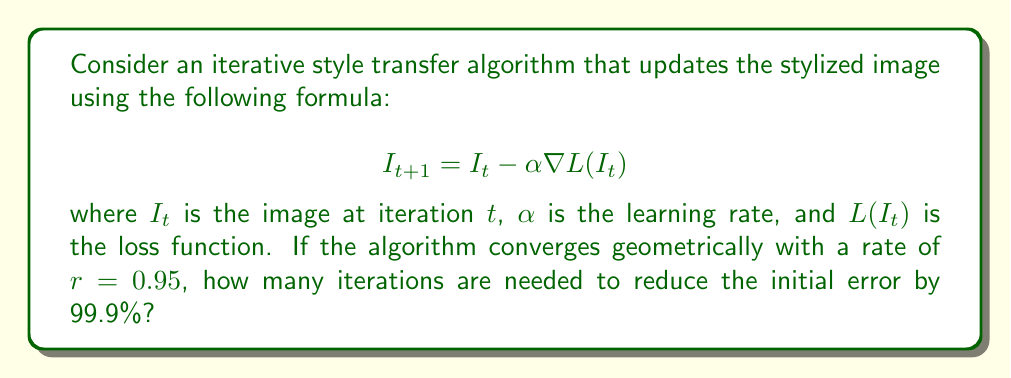Could you help me with this problem? Let's approach this step-by-step:

1) In geometric convergence, the error at iteration $t$ is given by:

   $$e_t = e_0 r^t$$

   where $e_0$ is the initial error and $r$ is the rate of convergence.

2) We want to find $t$ such that:

   $$\frac{e_t}{e_0} = 0.001$$ (as 99.9% reduction means 0.1% remaining)

3) Substituting the geometric convergence formula:

   $$\frac{e_0 r^t}{e_0} = 0.001$$

4) Simplifying:

   $$r^t = 0.001$$

5) Taking the natural logarithm of both sides:

   $$t \ln(r) = \ln(0.001)$$

6) Solving for $t$:

   $$t = \frac{\ln(0.001)}{\ln(r)}$$

7) Substituting $r = 0.95$:

   $$t = \frac{\ln(0.001)}{\ln(0.95)}$$

8) Calculating:

   $$t \approx 135.28$$

9) Since we need a whole number of iterations, we round up to ensure we reach the desired error reduction.
Answer: 136 iterations 